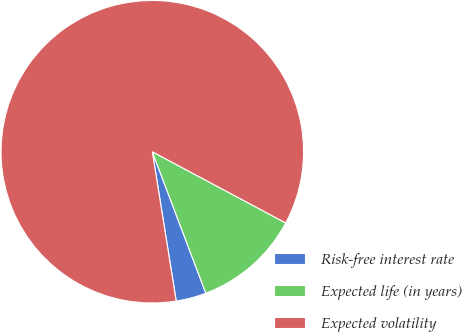Convert chart to OTSL. <chart><loc_0><loc_0><loc_500><loc_500><pie_chart><fcel>Risk-free interest rate<fcel>Expected life (in years)<fcel>Expected volatility<nl><fcel>3.23%<fcel>11.44%<fcel>85.33%<nl></chart> 